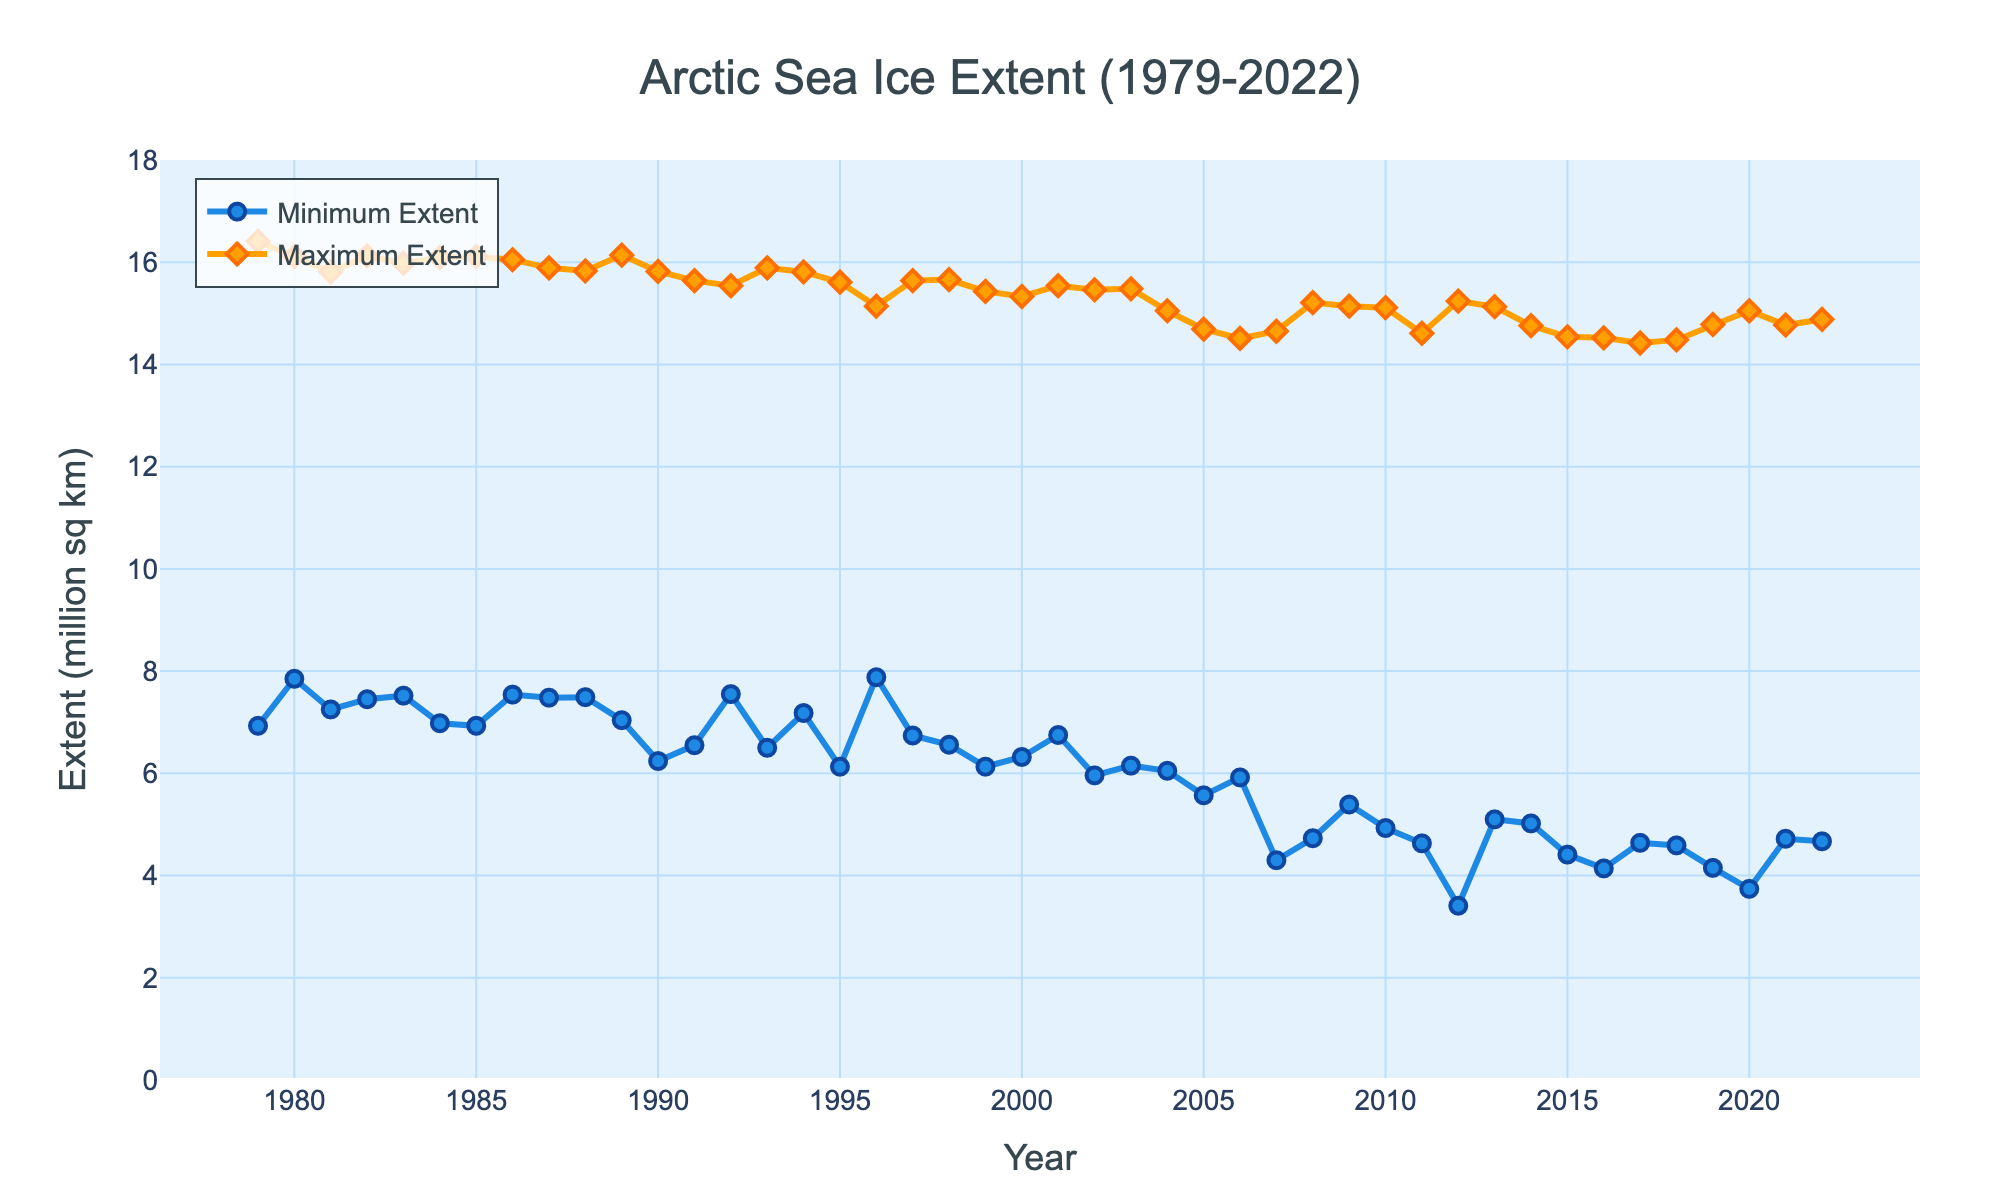Which year had the lowest minimum sea ice extent? The figure shows the minimum sea ice extent for each year. Locate the lowest point on the "Minimum Extent" line and identify the corresponding year.
Answer: 2012 Which year had the highest maximum sea ice extent? The figure shows the maximum sea ice extent for each year. Locate the highest point on the "Maximum Extent" line and identify the corresponding year.
Answer: 1979 What is the difference between the minimum and maximum sea ice extent in 2007? Locate the data points for the minimum and maximum sea ice extent in 2007. Subtract the minimum extent from the maximum extent to find the difference: 14.65 - 4.30 = 10.35 million sq km
Answer: 10.35 million sq km By how much did the minimum sea ice extent decrease from 2001 to 2012? Find the minimum sea ice extent for 2001 and 2012. The values are 6.75 and 3.41 million sq km, respectively. Subtract the 2012 value from the 2001 value: 6.75 - 3.41 = 3.34 million sq km
Answer: 3.34 million sq km Which year showed the greatest decline in minimum sea ice extent compared to the previous year? Examine the figure for drastic drops in the "Minimum Extent" line from one year to the next. Identify the segment with the steepest decline, which occurs between 2011 and 2012. Calculate the decline: 4.63 - 3.41 = 1.22 million sq km. Verify no other single year shows a larger drop.
Answer: 2012 What has been the overall trend in the minimum sea ice extent over the period displayed? Examine the general direction of the "Minimum Extent" line from 1979 to 2022. The trend shows a decline, indicating that the minimum sea ice extent has decreased over time.
Answer: Decreasing What was the average maximum sea ice extent from 2010 to 2020? Find the maximum sea ice extents for the years 2010 to 2020, inclusive. Sum these values and divide by the number of years (11): (15.11 + 14.61 + 15.24 + 15.13 + 14.76 + 14.54 + 14.52 + 14.42 + 14.48 + 14.78 + 15.05) / 11 = 14.73 million sq km
Answer: 14.73 million sq km Is there a visible pattern in the maximum sea ice extent over the years? Observe the "Maximum Extent" line on the graph. Note the general pattern, which shows fluctuating values with a slight downward trend over the years.
Answer: Decreasing trend with fluctuations Comparing the minimum and maximum sea ice extent lines, is there a similar trend in both? Examine both the "Minimum Extent" and "Maximum Extent" lines. Both lines show a general downward trend over the period displayed, suggesting a similar trend in decreasing sea ice extent.
Answer: Yes What has been the approximate difference in maximum sea ice extent between the start and end of the period displayed? Locate the maximum sea ice extent for the first year (1979) and the last year (2022). The values are 16.41 and 14.88 million sq km, respectively. Subtract the 2022 value from the 1979 value: 16.41 - 14.88 = 1.53 million sq km
Answer: 1.53 million sq km 